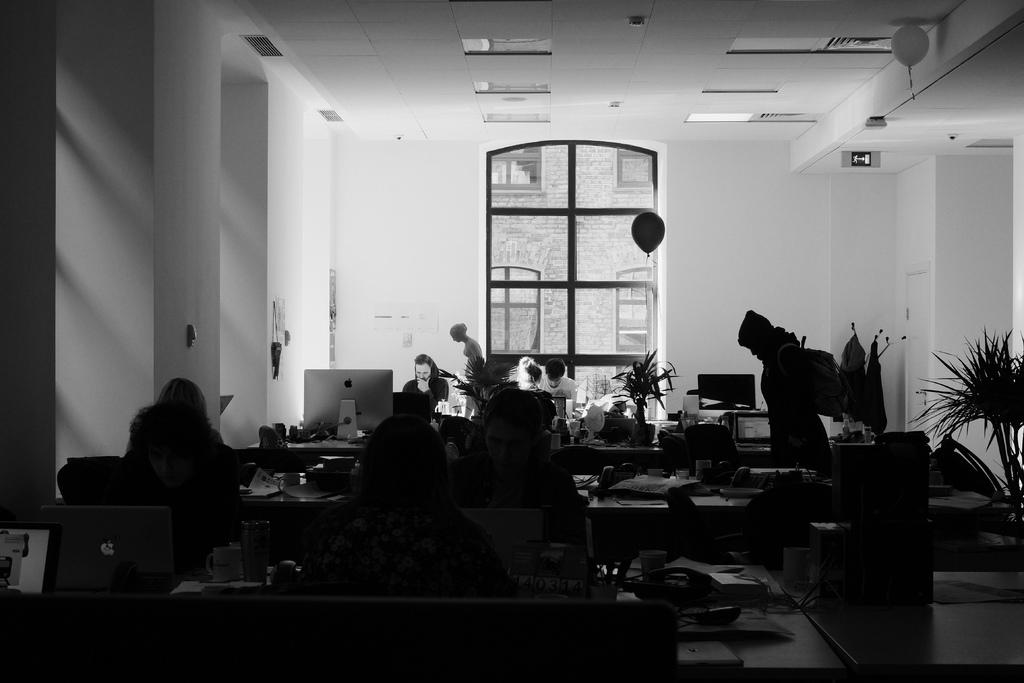What are the people in the room doing? The people in the room are working on laptops. Can you describe the room's environment? There is a plant and a balloon in the room. How many people are present in the room? The number of people is not specified, but there are people seated in the room. What type of competition is taking place in the room? There is no competition present in the image; the people are working on laptops. Can you read the note that is on the table in the room? There is no note mentioned in the image; only a plant and a balloon are described. 